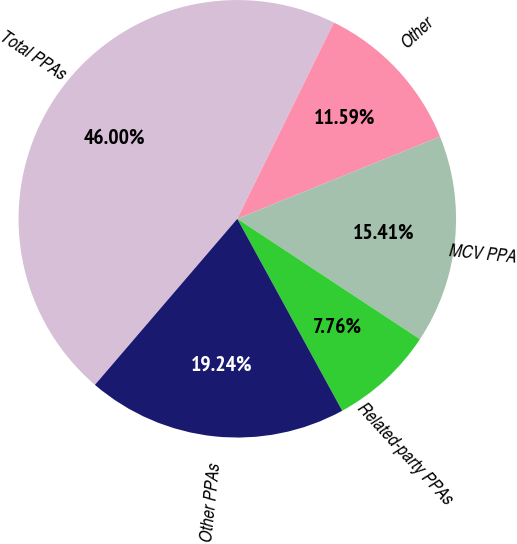Convert chart. <chart><loc_0><loc_0><loc_500><loc_500><pie_chart><fcel>Total PPAs<fcel>Other<fcel>MCV PPA<fcel>Related-party PPAs<fcel>Other PPAs<nl><fcel>46.0%<fcel>11.59%<fcel>15.41%<fcel>7.76%<fcel>19.24%<nl></chart> 